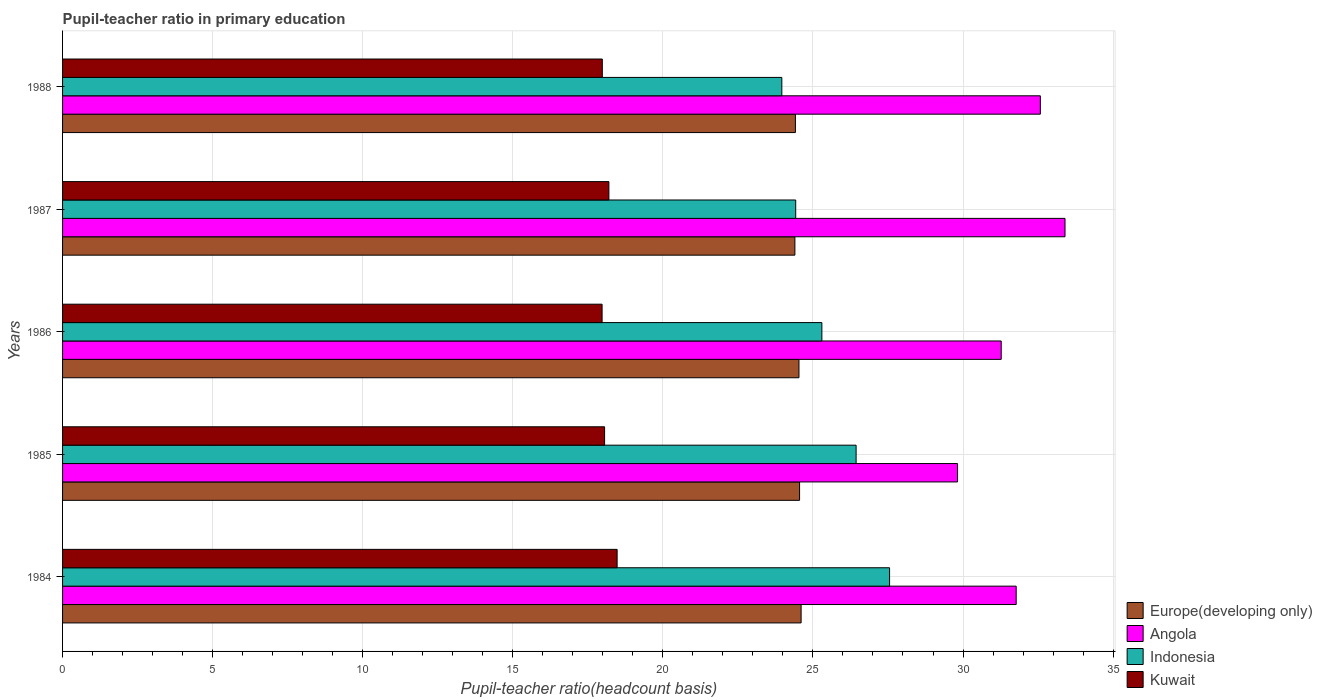How many different coloured bars are there?
Your response must be concise. 4. How many groups of bars are there?
Keep it short and to the point. 5. Are the number of bars per tick equal to the number of legend labels?
Give a very brief answer. Yes. Are the number of bars on each tick of the Y-axis equal?
Your answer should be compact. Yes. How many bars are there on the 2nd tick from the top?
Make the answer very short. 4. In how many cases, is the number of bars for a given year not equal to the number of legend labels?
Offer a very short reply. 0. What is the pupil-teacher ratio in primary education in Indonesia in 1986?
Make the answer very short. 25.3. Across all years, what is the maximum pupil-teacher ratio in primary education in Europe(developing only)?
Make the answer very short. 24.61. Across all years, what is the minimum pupil-teacher ratio in primary education in Europe(developing only)?
Make the answer very short. 24.4. In which year was the pupil-teacher ratio in primary education in Europe(developing only) maximum?
Ensure brevity in your answer.  1984. What is the total pupil-teacher ratio in primary education in Indonesia in the graph?
Provide a short and direct response. 127.68. What is the difference between the pupil-teacher ratio in primary education in Kuwait in 1984 and that in 1987?
Your answer should be very brief. 0.27. What is the difference between the pupil-teacher ratio in primary education in Kuwait in 1984 and the pupil-teacher ratio in primary education in Indonesia in 1986?
Offer a very short reply. -6.82. What is the average pupil-teacher ratio in primary education in Europe(developing only) per year?
Your answer should be compact. 24.5. In the year 1987, what is the difference between the pupil-teacher ratio in primary education in Kuwait and pupil-teacher ratio in primary education in Indonesia?
Provide a succinct answer. -6.22. What is the ratio of the pupil-teacher ratio in primary education in Europe(developing only) in 1987 to that in 1988?
Provide a succinct answer. 1. What is the difference between the highest and the second highest pupil-teacher ratio in primary education in Indonesia?
Your answer should be very brief. 1.11. What is the difference between the highest and the lowest pupil-teacher ratio in primary education in Angola?
Offer a very short reply. 3.58. In how many years, is the pupil-teacher ratio in primary education in Angola greater than the average pupil-teacher ratio in primary education in Angola taken over all years?
Provide a short and direct response. 3. Is it the case that in every year, the sum of the pupil-teacher ratio in primary education in Indonesia and pupil-teacher ratio in primary education in Kuwait is greater than the sum of pupil-teacher ratio in primary education in Europe(developing only) and pupil-teacher ratio in primary education in Angola?
Your response must be concise. No. What does the 1st bar from the top in 1985 represents?
Your answer should be compact. Kuwait. What does the 2nd bar from the bottom in 1984 represents?
Your answer should be very brief. Angola. Is it the case that in every year, the sum of the pupil-teacher ratio in primary education in Angola and pupil-teacher ratio in primary education in Kuwait is greater than the pupil-teacher ratio in primary education in Europe(developing only)?
Your answer should be compact. Yes. Are all the bars in the graph horizontal?
Offer a terse response. Yes. How many years are there in the graph?
Your answer should be very brief. 5. Where does the legend appear in the graph?
Provide a short and direct response. Bottom right. How many legend labels are there?
Give a very brief answer. 4. What is the title of the graph?
Your answer should be very brief. Pupil-teacher ratio in primary education. Does "Bermuda" appear as one of the legend labels in the graph?
Offer a terse response. No. What is the label or title of the X-axis?
Provide a succinct answer. Pupil-teacher ratio(headcount basis). What is the label or title of the Y-axis?
Keep it short and to the point. Years. What is the Pupil-teacher ratio(headcount basis) in Europe(developing only) in 1984?
Provide a succinct answer. 24.61. What is the Pupil-teacher ratio(headcount basis) of Angola in 1984?
Offer a very short reply. 31.77. What is the Pupil-teacher ratio(headcount basis) in Indonesia in 1984?
Provide a succinct answer. 27.55. What is the Pupil-teacher ratio(headcount basis) in Kuwait in 1984?
Ensure brevity in your answer.  18.48. What is the Pupil-teacher ratio(headcount basis) in Europe(developing only) in 1985?
Your answer should be compact. 24.55. What is the Pupil-teacher ratio(headcount basis) of Angola in 1985?
Make the answer very short. 29.82. What is the Pupil-teacher ratio(headcount basis) of Indonesia in 1985?
Offer a terse response. 26.44. What is the Pupil-teacher ratio(headcount basis) in Kuwait in 1985?
Offer a terse response. 18.06. What is the Pupil-teacher ratio(headcount basis) in Europe(developing only) in 1986?
Your response must be concise. 24.53. What is the Pupil-teacher ratio(headcount basis) of Angola in 1986?
Provide a short and direct response. 31.27. What is the Pupil-teacher ratio(headcount basis) in Indonesia in 1986?
Keep it short and to the point. 25.3. What is the Pupil-teacher ratio(headcount basis) of Kuwait in 1986?
Your answer should be compact. 17.98. What is the Pupil-teacher ratio(headcount basis) in Europe(developing only) in 1987?
Keep it short and to the point. 24.4. What is the Pupil-teacher ratio(headcount basis) in Angola in 1987?
Make the answer very short. 33.4. What is the Pupil-teacher ratio(headcount basis) of Indonesia in 1987?
Provide a short and direct response. 24.43. What is the Pupil-teacher ratio(headcount basis) of Kuwait in 1987?
Provide a short and direct response. 18.2. What is the Pupil-teacher ratio(headcount basis) in Europe(developing only) in 1988?
Offer a very short reply. 24.42. What is the Pupil-teacher ratio(headcount basis) in Angola in 1988?
Your answer should be very brief. 32.58. What is the Pupil-teacher ratio(headcount basis) of Indonesia in 1988?
Make the answer very short. 23.96. What is the Pupil-teacher ratio(headcount basis) of Kuwait in 1988?
Your response must be concise. 17.98. Across all years, what is the maximum Pupil-teacher ratio(headcount basis) in Europe(developing only)?
Provide a short and direct response. 24.61. Across all years, what is the maximum Pupil-teacher ratio(headcount basis) of Angola?
Ensure brevity in your answer.  33.4. Across all years, what is the maximum Pupil-teacher ratio(headcount basis) in Indonesia?
Give a very brief answer. 27.55. Across all years, what is the maximum Pupil-teacher ratio(headcount basis) in Kuwait?
Give a very brief answer. 18.48. Across all years, what is the minimum Pupil-teacher ratio(headcount basis) of Europe(developing only)?
Offer a terse response. 24.4. Across all years, what is the minimum Pupil-teacher ratio(headcount basis) in Angola?
Your answer should be very brief. 29.82. Across all years, what is the minimum Pupil-teacher ratio(headcount basis) in Indonesia?
Your response must be concise. 23.96. Across all years, what is the minimum Pupil-teacher ratio(headcount basis) in Kuwait?
Give a very brief answer. 17.98. What is the total Pupil-teacher ratio(headcount basis) in Europe(developing only) in the graph?
Provide a short and direct response. 122.51. What is the total Pupil-teacher ratio(headcount basis) of Angola in the graph?
Offer a very short reply. 158.84. What is the total Pupil-teacher ratio(headcount basis) of Indonesia in the graph?
Give a very brief answer. 127.68. What is the total Pupil-teacher ratio(headcount basis) in Kuwait in the graph?
Offer a terse response. 90.69. What is the difference between the Pupil-teacher ratio(headcount basis) in Europe(developing only) in 1984 and that in 1985?
Ensure brevity in your answer.  0.05. What is the difference between the Pupil-teacher ratio(headcount basis) in Angola in 1984 and that in 1985?
Give a very brief answer. 1.95. What is the difference between the Pupil-teacher ratio(headcount basis) of Indonesia in 1984 and that in 1985?
Your answer should be compact. 1.11. What is the difference between the Pupil-teacher ratio(headcount basis) in Kuwait in 1984 and that in 1985?
Provide a short and direct response. 0.42. What is the difference between the Pupil-teacher ratio(headcount basis) of Europe(developing only) in 1984 and that in 1986?
Ensure brevity in your answer.  0.07. What is the difference between the Pupil-teacher ratio(headcount basis) in Angola in 1984 and that in 1986?
Keep it short and to the point. 0.5. What is the difference between the Pupil-teacher ratio(headcount basis) of Indonesia in 1984 and that in 1986?
Your answer should be very brief. 2.26. What is the difference between the Pupil-teacher ratio(headcount basis) of Kuwait in 1984 and that in 1986?
Your answer should be compact. 0.5. What is the difference between the Pupil-teacher ratio(headcount basis) in Europe(developing only) in 1984 and that in 1987?
Your answer should be compact. 0.21. What is the difference between the Pupil-teacher ratio(headcount basis) of Angola in 1984 and that in 1987?
Provide a short and direct response. -1.63. What is the difference between the Pupil-teacher ratio(headcount basis) in Indonesia in 1984 and that in 1987?
Your response must be concise. 3.13. What is the difference between the Pupil-teacher ratio(headcount basis) of Kuwait in 1984 and that in 1987?
Your answer should be very brief. 0.27. What is the difference between the Pupil-teacher ratio(headcount basis) of Europe(developing only) in 1984 and that in 1988?
Provide a succinct answer. 0.19. What is the difference between the Pupil-teacher ratio(headcount basis) in Angola in 1984 and that in 1988?
Give a very brief answer. -0.8. What is the difference between the Pupil-teacher ratio(headcount basis) in Indonesia in 1984 and that in 1988?
Offer a terse response. 3.59. What is the difference between the Pupil-teacher ratio(headcount basis) of Kuwait in 1984 and that in 1988?
Make the answer very short. 0.49. What is the difference between the Pupil-teacher ratio(headcount basis) of Europe(developing only) in 1985 and that in 1986?
Provide a succinct answer. 0.02. What is the difference between the Pupil-teacher ratio(headcount basis) in Angola in 1985 and that in 1986?
Keep it short and to the point. -1.46. What is the difference between the Pupil-teacher ratio(headcount basis) of Indonesia in 1985 and that in 1986?
Your answer should be compact. 1.14. What is the difference between the Pupil-teacher ratio(headcount basis) of Kuwait in 1985 and that in 1986?
Provide a succinct answer. 0.08. What is the difference between the Pupil-teacher ratio(headcount basis) of Europe(developing only) in 1985 and that in 1987?
Your answer should be compact. 0.16. What is the difference between the Pupil-teacher ratio(headcount basis) in Angola in 1985 and that in 1987?
Your answer should be compact. -3.58. What is the difference between the Pupil-teacher ratio(headcount basis) of Indonesia in 1985 and that in 1987?
Offer a very short reply. 2.01. What is the difference between the Pupil-teacher ratio(headcount basis) of Kuwait in 1985 and that in 1987?
Offer a very short reply. -0.14. What is the difference between the Pupil-teacher ratio(headcount basis) of Europe(developing only) in 1985 and that in 1988?
Keep it short and to the point. 0.14. What is the difference between the Pupil-teacher ratio(headcount basis) in Angola in 1985 and that in 1988?
Ensure brevity in your answer.  -2.76. What is the difference between the Pupil-teacher ratio(headcount basis) in Indonesia in 1985 and that in 1988?
Give a very brief answer. 2.48. What is the difference between the Pupil-teacher ratio(headcount basis) in Kuwait in 1985 and that in 1988?
Provide a short and direct response. 0.08. What is the difference between the Pupil-teacher ratio(headcount basis) of Europe(developing only) in 1986 and that in 1987?
Your answer should be compact. 0.14. What is the difference between the Pupil-teacher ratio(headcount basis) in Angola in 1986 and that in 1987?
Give a very brief answer. -2.13. What is the difference between the Pupil-teacher ratio(headcount basis) of Indonesia in 1986 and that in 1987?
Provide a succinct answer. 0.87. What is the difference between the Pupil-teacher ratio(headcount basis) of Kuwait in 1986 and that in 1987?
Make the answer very short. -0.23. What is the difference between the Pupil-teacher ratio(headcount basis) in Europe(developing only) in 1986 and that in 1988?
Your answer should be very brief. 0.12. What is the difference between the Pupil-teacher ratio(headcount basis) in Angola in 1986 and that in 1988?
Your answer should be very brief. -1.3. What is the difference between the Pupil-teacher ratio(headcount basis) in Indonesia in 1986 and that in 1988?
Make the answer very short. 1.33. What is the difference between the Pupil-teacher ratio(headcount basis) of Kuwait in 1986 and that in 1988?
Keep it short and to the point. -0.01. What is the difference between the Pupil-teacher ratio(headcount basis) in Europe(developing only) in 1987 and that in 1988?
Your answer should be compact. -0.02. What is the difference between the Pupil-teacher ratio(headcount basis) in Angola in 1987 and that in 1988?
Make the answer very short. 0.82. What is the difference between the Pupil-teacher ratio(headcount basis) in Indonesia in 1987 and that in 1988?
Provide a short and direct response. 0.46. What is the difference between the Pupil-teacher ratio(headcount basis) in Kuwait in 1987 and that in 1988?
Offer a very short reply. 0.22. What is the difference between the Pupil-teacher ratio(headcount basis) of Europe(developing only) in 1984 and the Pupil-teacher ratio(headcount basis) of Angola in 1985?
Provide a short and direct response. -5.21. What is the difference between the Pupil-teacher ratio(headcount basis) in Europe(developing only) in 1984 and the Pupil-teacher ratio(headcount basis) in Indonesia in 1985?
Offer a terse response. -1.83. What is the difference between the Pupil-teacher ratio(headcount basis) in Europe(developing only) in 1984 and the Pupil-teacher ratio(headcount basis) in Kuwait in 1985?
Provide a short and direct response. 6.55. What is the difference between the Pupil-teacher ratio(headcount basis) of Angola in 1984 and the Pupil-teacher ratio(headcount basis) of Indonesia in 1985?
Your response must be concise. 5.33. What is the difference between the Pupil-teacher ratio(headcount basis) of Angola in 1984 and the Pupil-teacher ratio(headcount basis) of Kuwait in 1985?
Make the answer very short. 13.71. What is the difference between the Pupil-teacher ratio(headcount basis) in Indonesia in 1984 and the Pupil-teacher ratio(headcount basis) in Kuwait in 1985?
Offer a very short reply. 9.49. What is the difference between the Pupil-teacher ratio(headcount basis) in Europe(developing only) in 1984 and the Pupil-teacher ratio(headcount basis) in Angola in 1986?
Your response must be concise. -6.67. What is the difference between the Pupil-teacher ratio(headcount basis) of Europe(developing only) in 1984 and the Pupil-teacher ratio(headcount basis) of Indonesia in 1986?
Offer a very short reply. -0.69. What is the difference between the Pupil-teacher ratio(headcount basis) of Europe(developing only) in 1984 and the Pupil-teacher ratio(headcount basis) of Kuwait in 1986?
Offer a very short reply. 6.63. What is the difference between the Pupil-teacher ratio(headcount basis) in Angola in 1984 and the Pupil-teacher ratio(headcount basis) in Indonesia in 1986?
Give a very brief answer. 6.47. What is the difference between the Pupil-teacher ratio(headcount basis) of Angola in 1984 and the Pupil-teacher ratio(headcount basis) of Kuwait in 1986?
Your answer should be compact. 13.8. What is the difference between the Pupil-teacher ratio(headcount basis) of Indonesia in 1984 and the Pupil-teacher ratio(headcount basis) of Kuwait in 1986?
Keep it short and to the point. 9.58. What is the difference between the Pupil-teacher ratio(headcount basis) of Europe(developing only) in 1984 and the Pupil-teacher ratio(headcount basis) of Angola in 1987?
Your answer should be compact. -8.79. What is the difference between the Pupil-teacher ratio(headcount basis) in Europe(developing only) in 1984 and the Pupil-teacher ratio(headcount basis) in Indonesia in 1987?
Offer a terse response. 0.18. What is the difference between the Pupil-teacher ratio(headcount basis) in Europe(developing only) in 1984 and the Pupil-teacher ratio(headcount basis) in Kuwait in 1987?
Your answer should be very brief. 6.4. What is the difference between the Pupil-teacher ratio(headcount basis) of Angola in 1984 and the Pupil-teacher ratio(headcount basis) of Indonesia in 1987?
Offer a terse response. 7.35. What is the difference between the Pupil-teacher ratio(headcount basis) of Angola in 1984 and the Pupil-teacher ratio(headcount basis) of Kuwait in 1987?
Your answer should be compact. 13.57. What is the difference between the Pupil-teacher ratio(headcount basis) in Indonesia in 1984 and the Pupil-teacher ratio(headcount basis) in Kuwait in 1987?
Keep it short and to the point. 9.35. What is the difference between the Pupil-teacher ratio(headcount basis) in Europe(developing only) in 1984 and the Pupil-teacher ratio(headcount basis) in Angola in 1988?
Your response must be concise. -7.97. What is the difference between the Pupil-teacher ratio(headcount basis) of Europe(developing only) in 1984 and the Pupil-teacher ratio(headcount basis) of Indonesia in 1988?
Your answer should be very brief. 0.64. What is the difference between the Pupil-teacher ratio(headcount basis) of Europe(developing only) in 1984 and the Pupil-teacher ratio(headcount basis) of Kuwait in 1988?
Provide a succinct answer. 6.62. What is the difference between the Pupil-teacher ratio(headcount basis) of Angola in 1984 and the Pupil-teacher ratio(headcount basis) of Indonesia in 1988?
Offer a very short reply. 7.81. What is the difference between the Pupil-teacher ratio(headcount basis) of Angola in 1984 and the Pupil-teacher ratio(headcount basis) of Kuwait in 1988?
Your response must be concise. 13.79. What is the difference between the Pupil-teacher ratio(headcount basis) of Indonesia in 1984 and the Pupil-teacher ratio(headcount basis) of Kuwait in 1988?
Give a very brief answer. 9.57. What is the difference between the Pupil-teacher ratio(headcount basis) in Europe(developing only) in 1985 and the Pupil-teacher ratio(headcount basis) in Angola in 1986?
Keep it short and to the point. -6.72. What is the difference between the Pupil-teacher ratio(headcount basis) of Europe(developing only) in 1985 and the Pupil-teacher ratio(headcount basis) of Indonesia in 1986?
Keep it short and to the point. -0.74. What is the difference between the Pupil-teacher ratio(headcount basis) in Europe(developing only) in 1985 and the Pupil-teacher ratio(headcount basis) in Kuwait in 1986?
Offer a very short reply. 6.58. What is the difference between the Pupil-teacher ratio(headcount basis) in Angola in 1985 and the Pupil-teacher ratio(headcount basis) in Indonesia in 1986?
Your response must be concise. 4.52. What is the difference between the Pupil-teacher ratio(headcount basis) in Angola in 1985 and the Pupil-teacher ratio(headcount basis) in Kuwait in 1986?
Give a very brief answer. 11.84. What is the difference between the Pupil-teacher ratio(headcount basis) of Indonesia in 1985 and the Pupil-teacher ratio(headcount basis) of Kuwait in 1986?
Ensure brevity in your answer.  8.46. What is the difference between the Pupil-teacher ratio(headcount basis) of Europe(developing only) in 1985 and the Pupil-teacher ratio(headcount basis) of Angola in 1987?
Make the answer very short. -8.84. What is the difference between the Pupil-teacher ratio(headcount basis) of Europe(developing only) in 1985 and the Pupil-teacher ratio(headcount basis) of Indonesia in 1987?
Ensure brevity in your answer.  0.13. What is the difference between the Pupil-teacher ratio(headcount basis) of Europe(developing only) in 1985 and the Pupil-teacher ratio(headcount basis) of Kuwait in 1987?
Provide a short and direct response. 6.35. What is the difference between the Pupil-teacher ratio(headcount basis) in Angola in 1985 and the Pupil-teacher ratio(headcount basis) in Indonesia in 1987?
Keep it short and to the point. 5.39. What is the difference between the Pupil-teacher ratio(headcount basis) of Angola in 1985 and the Pupil-teacher ratio(headcount basis) of Kuwait in 1987?
Your response must be concise. 11.62. What is the difference between the Pupil-teacher ratio(headcount basis) of Indonesia in 1985 and the Pupil-teacher ratio(headcount basis) of Kuwait in 1987?
Provide a succinct answer. 8.24. What is the difference between the Pupil-teacher ratio(headcount basis) of Europe(developing only) in 1985 and the Pupil-teacher ratio(headcount basis) of Angola in 1988?
Provide a succinct answer. -8.02. What is the difference between the Pupil-teacher ratio(headcount basis) of Europe(developing only) in 1985 and the Pupil-teacher ratio(headcount basis) of Indonesia in 1988?
Give a very brief answer. 0.59. What is the difference between the Pupil-teacher ratio(headcount basis) in Europe(developing only) in 1985 and the Pupil-teacher ratio(headcount basis) in Kuwait in 1988?
Your answer should be compact. 6.57. What is the difference between the Pupil-teacher ratio(headcount basis) in Angola in 1985 and the Pupil-teacher ratio(headcount basis) in Indonesia in 1988?
Your answer should be compact. 5.85. What is the difference between the Pupil-teacher ratio(headcount basis) in Angola in 1985 and the Pupil-teacher ratio(headcount basis) in Kuwait in 1988?
Provide a succinct answer. 11.84. What is the difference between the Pupil-teacher ratio(headcount basis) in Indonesia in 1985 and the Pupil-teacher ratio(headcount basis) in Kuwait in 1988?
Provide a short and direct response. 8.46. What is the difference between the Pupil-teacher ratio(headcount basis) in Europe(developing only) in 1986 and the Pupil-teacher ratio(headcount basis) in Angola in 1987?
Provide a short and direct response. -8.86. What is the difference between the Pupil-teacher ratio(headcount basis) of Europe(developing only) in 1986 and the Pupil-teacher ratio(headcount basis) of Indonesia in 1987?
Offer a terse response. 0.11. What is the difference between the Pupil-teacher ratio(headcount basis) of Europe(developing only) in 1986 and the Pupil-teacher ratio(headcount basis) of Kuwait in 1987?
Give a very brief answer. 6.33. What is the difference between the Pupil-teacher ratio(headcount basis) in Angola in 1986 and the Pupil-teacher ratio(headcount basis) in Indonesia in 1987?
Make the answer very short. 6.85. What is the difference between the Pupil-teacher ratio(headcount basis) in Angola in 1986 and the Pupil-teacher ratio(headcount basis) in Kuwait in 1987?
Keep it short and to the point. 13.07. What is the difference between the Pupil-teacher ratio(headcount basis) in Indonesia in 1986 and the Pupil-teacher ratio(headcount basis) in Kuwait in 1987?
Your response must be concise. 7.1. What is the difference between the Pupil-teacher ratio(headcount basis) of Europe(developing only) in 1986 and the Pupil-teacher ratio(headcount basis) of Angola in 1988?
Your answer should be very brief. -8.04. What is the difference between the Pupil-teacher ratio(headcount basis) of Europe(developing only) in 1986 and the Pupil-teacher ratio(headcount basis) of Indonesia in 1988?
Provide a succinct answer. 0.57. What is the difference between the Pupil-teacher ratio(headcount basis) of Europe(developing only) in 1986 and the Pupil-teacher ratio(headcount basis) of Kuwait in 1988?
Make the answer very short. 6.55. What is the difference between the Pupil-teacher ratio(headcount basis) of Angola in 1986 and the Pupil-teacher ratio(headcount basis) of Indonesia in 1988?
Keep it short and to the point. 7.31. What is the difference between the Pupil-teacher ratio(headcount basis) in Angola in 1986 and the Pupil-teacher ratio(headcount basis) in Kuwait in 1988?
Your response must be concise. 13.29. What is the difference between the Pupil-teacher ratio(headcount basis) of Indonesia in 1986 and the Pupil-teacher ratio(headcount basis) of Kuwait in 1988?
Your answer should be very brief. 7.32. What is the difference between the Pupil-teacher ratio(headcount basis) in Europe(developing only) in 1987 and the Pupil-teacher ratio(headcount basis) in Angola in 1988?
Provide a short and direct response. -8.18. What is the difference between the Pupil-teacher ratio(headcount basis) of Europe(developing only) in 1987 and the Pupil-teacher ratio(headcount basis) of Indonesia in 1988?
Provide a short and direct response. 0.44. What is the difference between the Pupil-teacher ratio(headcount basis) in Europe(developing only) in 1987 and the Pupil-teacher ratio(headcount basis) in Kuwait in 1988?
Ensure brevity in your answer.  6.42. What is the difference between the Pupil-teacher ratio(headcount basis) of Angola in 1987 and the Pupil-teacher ratio(headcount basis) of Indonesia in 1988?
Provide a short and direct response. 9.43. What is the difference between the Pupil-teacher ratio(headcount basis) of Angola in 1987 and the Pupil-teacher ratio(headcount basis) of Kuwait in 1988?
Provide a short and direct response. 15.42. What is the difference between the Pupil-teacher ratio(headcount basis) in Indonesia in 1987 and the Pupil-teacher ratio(headcount basis) in Kuwait in 1988?
Your answer should be very brief. 6.44. What is the average Pupil-teacher ratio(headcount basis) in Europe(developing only) per year?
Your answer should be compact. 24.5. What is the average Pupil-teacher ratio(headcount basis) of Angola per year?
Your answer should be compact. 31.77. What is the average Pupil-teacher ratio(headcount basis) in Indonesia per year?
Make the answer very short. 25.54. What is the average Pupil-teacher ratio(headcount basis) of Kuwait per year?
Offer a terse response. 18.14. In the year 1984, what is the difference between the Pupil-teacher ratio(headcount basis) of Europe(developing only) and Pupil-teacher ratio(headcount basis) of Angola?
Keep it short and to the point. -7.17. In the year 1984, what is the difference between the Pupil-teacher ratio(headcount basis) of Europe(developing only) and Pupil-teacher ratio(headcount basis) of Indonesia?
Offer a terse response. -2.95. In the year 1984, what is the difference between the Pupil-teacher ratio(headcount basis) of Europe(developing only) and Pupil-teacher ratio(headcount basis) of Kuwait?
Offer a very short reply. 6.13. In the year 1984, what is the difference between the Pupil-teacher ratio(headcount basis) in Angola and Pupil-teacher ratio(headcount basis) in Indonesia?
Provide a succinct answer. 4.22. In the year 1984, what is the difference between the Pupil-teacher ratio(headcount basis) in Angola and Pupil-teacher ratio(headcount basis) in Kuwait?
Ensure brevity in your answer.  13.3. In the year 1984, what is the difference between the Pupil-teacher ratio(headcount basis) of Indonesia and Pupil-teacher ratio(headcount basis) of Kuwait?
Offer a very short reply. 9.08. In the year 1985, what is the difference between the Pupil-teacher ratio(headcount basis) of Europe(developing only) and Pupil-teacher ratio(headcount basis) of Angola?
Give a very brief answer. -5.26. In the year 1985, what is the difference between the Pupil-teacher ratio(headcount basis) in Europe(developing only) and Pupil-teacher ratio(headcount basis) in Indonesia?
Your answer should be compact. -1.88. In the year 1985, what is the difference between the Pupil-teacher ratio(headcount basis) in Europe(developing only) and Pupil-teacher ratio(headcount basis) in Kuwait?
Give a very brief answer. 6.5. In the year 1985, what is the difference between the Pupil-teacher ratio(headcount basis) in Angola and Pupil-teacher ratio(headcount basis) in Indonesia?
Offer a very short reply. 3.38. In the year 1985, what is the difference between the Pupil-teacher ratio(headcount basis) in Angola and Pupil-teacher ratio(headcount basis) in Kuwait?
Offer a terse response. 11.76. In the year 1985, what is the difference between the Pupil-teacher ratio(headcount basis) in Indonesia and Pupil-teacher ratio(headcount basis) in Kuwait?
Provide a short and direct response. 8.38. In the year 1986, what is the difference between the Pupil-teacher ratio(headcount basis) of Europe(developing only) and Pupil-teacher ratio(headcount basis) of Angola?
Provide a short and direct response. -6.74. In the year 1986, what is the difference between the Pupil-teacher ratio(headcount basis) in Europe(developing only) and Pupil-teacher ratio(headcount basis) in Indonesia?
Provide a succinct answer. -0.76. In the year 1986, what is the difference between the Pupil-teacher ratio(headcount basis) in Europe(developing only) and Pupil-teacher ratio(headcount basis) in Kuwait?
Your answer should be very brief. 6.56. In the year 1986, what is the difference between the Pupil-teacher ratio(headcount basis) in Angola and Pupil-teacher ratio(headcount basis) in Indonesia?
Offer a very short reply. 5.98. In the year 1986, what is the difference between the Pupil-teacher ratio(headcount basis) in Angola and Pupil-teacher ratio(headcount basis) in Kuwait?
Keep it short and to the point. 13.3. In the year 1986, what is the difference between the Pupil-teacher ratio(headcount basis) of Indonesia and Pupil-teacher ratio(headcount basis) of Kuwait?
Your answer should be compact. 7.32. In the year 1987, what is the difference between the Pupil-teacher ratio(headcount basis) of Europe(developing only) and Pupil-teacher ratio(headcount basis) of Angola?
Provide a short and direct response. -9. In the year 1987, what is the difference between the Pupil-teacher ratio(headcount basis) of Europe(developing only) and Pupil-teacher ratio(headcount basis) of Indonesia?
Ensure brevity in your answer.  -0.03. In the year 1987, what is the difference between the Pupil-teacher ratio(headcount basis) of Europe(developing only) and Pupil-teacher ratio(headcount basis) of Kuwait?
Your answer should be very brief. 6.2. In the year 1987, what is the difference between the Pupil-teacher ratio(headcount basis) of Angola and Pupil-teacher ratio(headcount basis) of Indonesia?
Provide a succinct answer. 8.97. In the year 1987, what is the difference between the Pupil-teacher ratio(headcount basis) of Angola and Pupil-teacher ratio(headcount basis) of Kuwait?
Your answer should be very brief. 15.2. In the year 1987, what is the difference between the Pupil-teacher ratio(headcount basis) of Indonesia and Pupil-teacher ratio(headcount basis) of Kuwait?
Ensure brevity in your answer.  6.22. In the year 1988, what is the difference between the Pupil-teacher ratio(headcount basis) in Europe(developing only) and Pupil-teacher ratio(headcount basis) in Angola?
Offer a very short reply. -8.16. In the year 1988, what is the difference between the Pupil-teacher ratio(headcount basis) of Europe(developing only) and Pupil-teacher ratio(headcount basis) of Indonesia?
Give a very brief answer. 0.45. In the year 1988, what is the difference between the Pupil-teacher ratio(headcount basis) of Europe(developing only) and Pupil-teacher ratio(headcount basis) of Kuwait?
Your response must be concise. 6.43. In the year 1988, what is the difference between the Pupil-teacher ratio(headcount basis) of Angola and Pupil-teacher ratio(headcount basis) of Indonesia?
Keep it short and to the point. 8.61. In the year 1988, what is the difference between the Pupil-teacher ratio(headcount basis) of Angola and Pupil-teacher ratio(headcount basis) of Kuwait?
Offer a terse response. 14.59. In the year 1988, what is the difference between the Pupil-teacher ratio(headcount basis) in Indonesia and Pupil-teacher ratio(headcount basis) in Kuwait?
Offer a very short reply. 5.98. What is the ratio of the Pupil-teacher ratio(headcount basis) in Angola in 1984 to that in 1985?
Provide a short and direct response. 1.07. What is the ratio of the Pupil-teacher ratio(headcount basis) of Indonesia in 1984 to that in 1985?
Your response must be concise. 1.04. What is the ratio of the Pupil-teacher ratio(headcount basis) in Kuwait in 1984 to that in 1985?
Provide a succinct answer. 1.02. What is the ratio of the Pupil-teacher ratio(headcount basis) in Angola in 1984 to that in 1986?
Give a very brief answer. 1.02. What is the ratio of the Pupil-teacher ratio(headcount basis) of Indonesia in 1984 to that in 1986?
Your response must be concise. 1.09. What is the ratio of the Pupil-teacher ratio(headcount basis) of Kuwait in 1984 to that in 1986?
Ensure brevity in your answer.  1.03. What is the ratio of the Pupil-teacher ratio(headcount basis) of Europe(developing only) in 1984 to that in 1987?
Your answer should be compact. 1.01. What is the ratio of the Pupil-teacher ratio(headcount basis) in Angola in 1984 to that in 1987?
Give a very brief answer. 0.95. What is the ratio of the Pupil-teacher ratio(headcount basis) of Indonesia in 1984 to that in 1987?
Offer a very short reply. 1.13. What is the ratio of the Pupil-teacher ratio(headcount basis) in Kuwait in 1984 to that in 1987?
Make the answer very short. 1.02. What is the ratio of the Pupil-teacher ratio(headcount basis) in Europe(developing only) in 1984 to that in 1988?
Provide a short and direct response. 1.01. What is the ratio of the Pupil-teacher ratio(headcount basis) in Angola in 1984 to that in 1988?
Provide a short and direct response. 0.98. What is the ratio of the Pupil-teacher ratio(headcount basis) in Indonesia in 1984 to that in 1988?
Keep it short and to the point. 1.15. What is the ratio of the Pupil-teacher ratio(headcount basis) of Kuwait in 1984 to that in 1988?
Offer a terse response. 1.03. What is the ratio of the Pupil-teacher ratio(headcount basis) in Angola in 1985 to that in 1986?
Keep it short and to the point. 0.95. What is the ratio of the Pupil-teacher ratio(headcount basis) in Indonesia in 1985 to that in 1986?
Ensure brevity in your answer.  1.05. What is the ratio of the Pupil-teacher ratio(headcount basis) in Kuwait in 1985 to that in 1986?
Make the answer very short. 1. What is the ratio of the Pupil-teacher ratio(headcount basis) in Europe(developing only) in 1985 to that in 1987?
Provide a short and direct response. 1.01. What is the ratio of the Pupil-teacher ratio(headcount basis) in Angola in 1985 to that in 1987?
Ensure brevity in your answer.  0.89. What is the ratio of the Pupil-teacher ratio(headcount basis) in Indonesia in 1985 to that in 1987?
Your answer should be compact. 1.08. What is the ratio of the Pupil-teacher ratio(headcount basis) of Kuwait in 1985 to that in 1987?
Your response must be concise. 0.99. What is the ratio of the Pupil-teacher ratio(headcount basis) in Europe(developing only) in 1985 to that in 1988?
Your response must be concise. 1.01. What is the ratio of the Pupil-teacher ratio(headcount basis) in Angola in 1985 to that in 1988?
Offer a terse response. 0.92. What is the ratio of the Pupil-teacher ratio(headcount basis) of Indonesia in 1985 to that in 1988?
Your response must be concise. 1.1. What is the ratio of the Pupil-teacher ratio(headcount basis) of Kuwait in 1985 to that in 1988?
Offer a very short reply. 1. What is the ratio of the Pupil-teacher ratio(headcount basis) of Europe(developing only) in 1986 to that in 1987?
Your answer should be compact. 1.01. What is the ratio of the Pupil-teacher ratio(headcount basis) of Angola in 1986 to that in 1987?
Your answer should be very brief. 0.94. What is the ratio of the Pupil-teacher ratio(headcount basis) in Indonesia in 1986 to that in 1987?
Your answer should be very brief. 1.04. What is the ratio of the Pupil-teacher ratio(headcount basis) in Kuwait in 1986 to that in 1987?
Your answer should be very brief. 0.99. What is the ratio of the Pupil-teacher ratio(headcount basis) of Europe(developing only) in 1986 to that in 1988?
Your response must be concise. 1. What is the ratio of the Pupil-teacher ratio(headcount basis) in Angola in 1986 to that in 1988?
Offer a very short reply. 0.96. What is the ratio of the Pupil-teacher ratio(headcount basis) of Indonesia in 1986 to that in 1988?
Give a very brief answer. 1.06. What is the ratio of the Pupil-teacher ratio(headcount basis) in Kuwait in 1986 to that in 1988?
Keep it short and to the point. 1. What is the ratio of the Pupil-teacher ratio(headcount basis) of Europe(developing only) in 1987 to that in 1988?
Provide a succinct answer. 1. What is the ratio of the Pupil-teacher ratio(headcount basis) of Angola in 1987 to that in 1988?
Your answer should be compact. 1.03. What is the ratio of the Pupil-teacher ratio(headcount basis) of Indonesia in 1987 to that in 1988?
Your answer should be compact. 1.02. What is the ratio of the Pupil-teacher ratio(headcount basis) in Kuwait in 1987 to that in 1988?
Offer a very short reply. 1.01. What is the difference between the highest and the second highest Pupil-teacher ratio(headcount basis) of Europe(developing only)?
Your answer should be very brief. 0.05. What is the difference between the highest and the second highest Pupil-teacher ratio(headcount basis) in Angola?
Offer a very short reply. 0.82. What is the difference between the highest and the second highest Pupil-teacher ratio(headcount basis) in Indonesia?
Your answer should be compact. 1.11. What is the difference between the highest and the second highest Pupil-teacher ratio(headcount basis) in Kuwait?
Your answer should be compact. 0.27. What is the difference between the highest and the lowest Pupil-teacher ratio(headcount basis) in Europe(developing only)?
Offer a very short reply. 0.21. What is the difference between the highest and the lowest Pupil-teacher ratio(headcount basis) in Angola?
Your response must be concise. 3.58. What is the difference between the highest and the lowest Pupil-teacher ratio(headcount basis) in Indonesia?
Ensure brevity in your answer.  3.59. What is the difference between the highest and the lowest Pupil-teacher ratio(headcount basis) of Kuwait?
Offer a terse response. 0.5. 